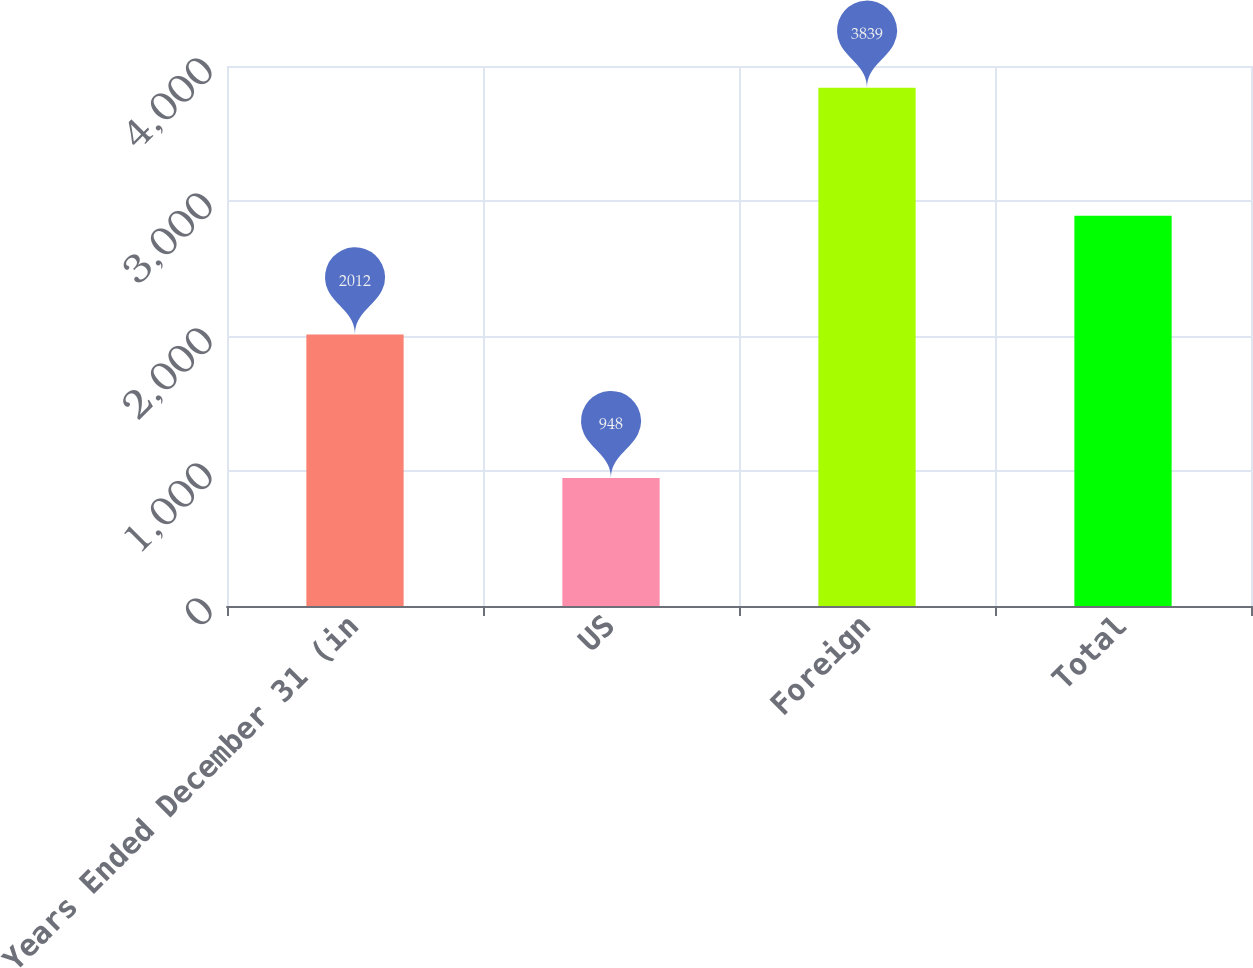Convert chart. <chart><loc_0><loc_0><loc_500><loc_500><bar_chart><fcel>Years Ended December 31 (in<fcel>US<fcel>Foreign<fcel>Total<nl><fcel>2012<fcel>948<fcel>3839<fcel>2891<nl></chart> 